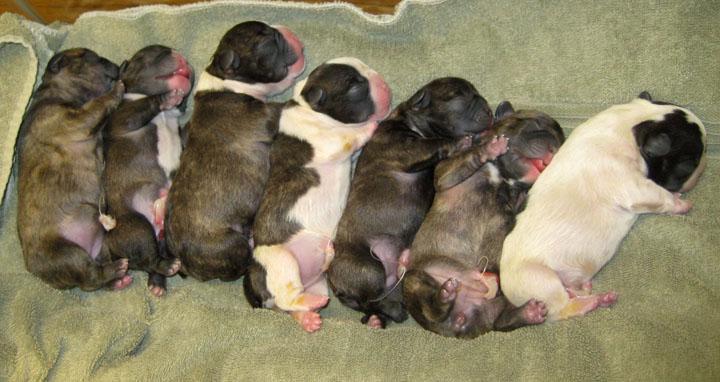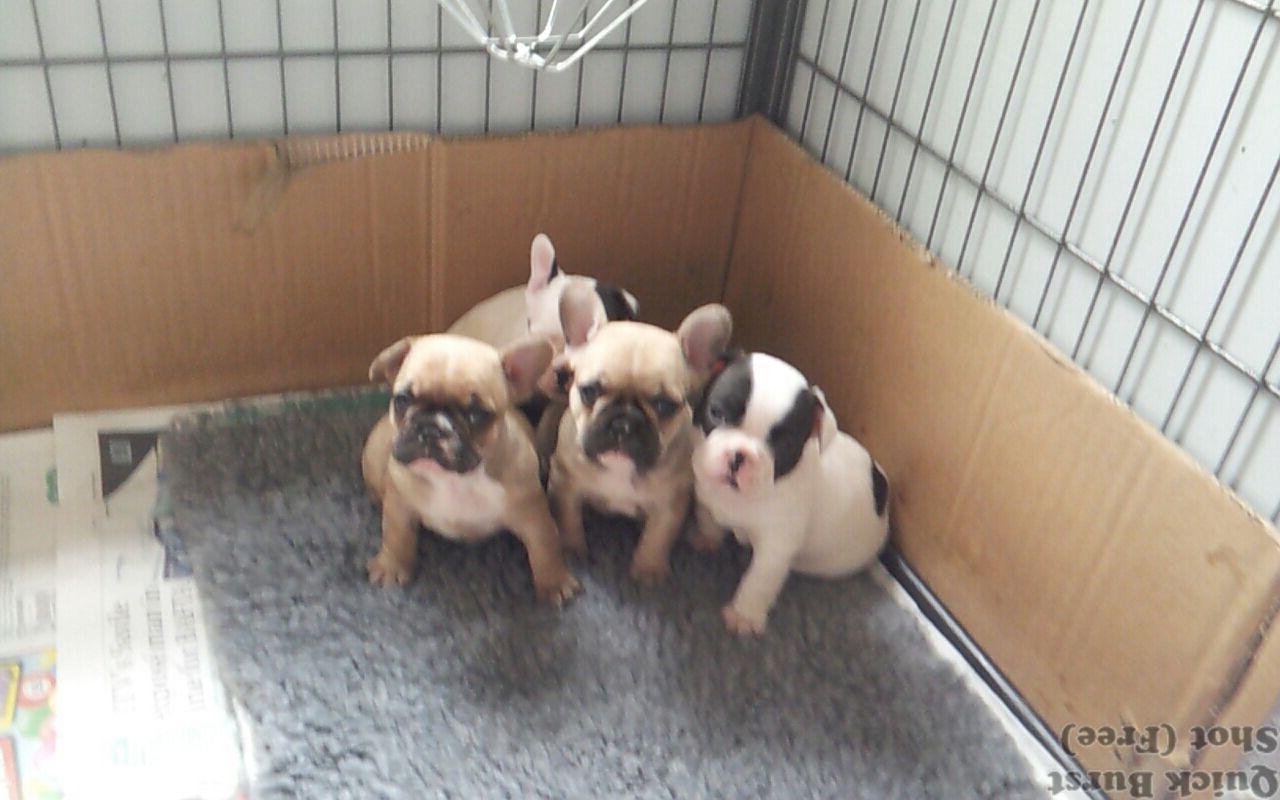The first image is the image on the left, the second image is the image on the right. Assess this claim about the two images: "One image contains more than 7 puppies.". Correct or not? Answer yes or no. No. The first image is the image on the left, the second image is the image on the right. Assess this claim about the two images: "There are at least four animals in the image on the right.". Correct or not? Answer yes or no. No. The first image is the image on the left, the second image is the image on the right. For the images displayed, is the sentence "The dogs on the left are lined up." factually correct? Answer yes or no. Yes. 